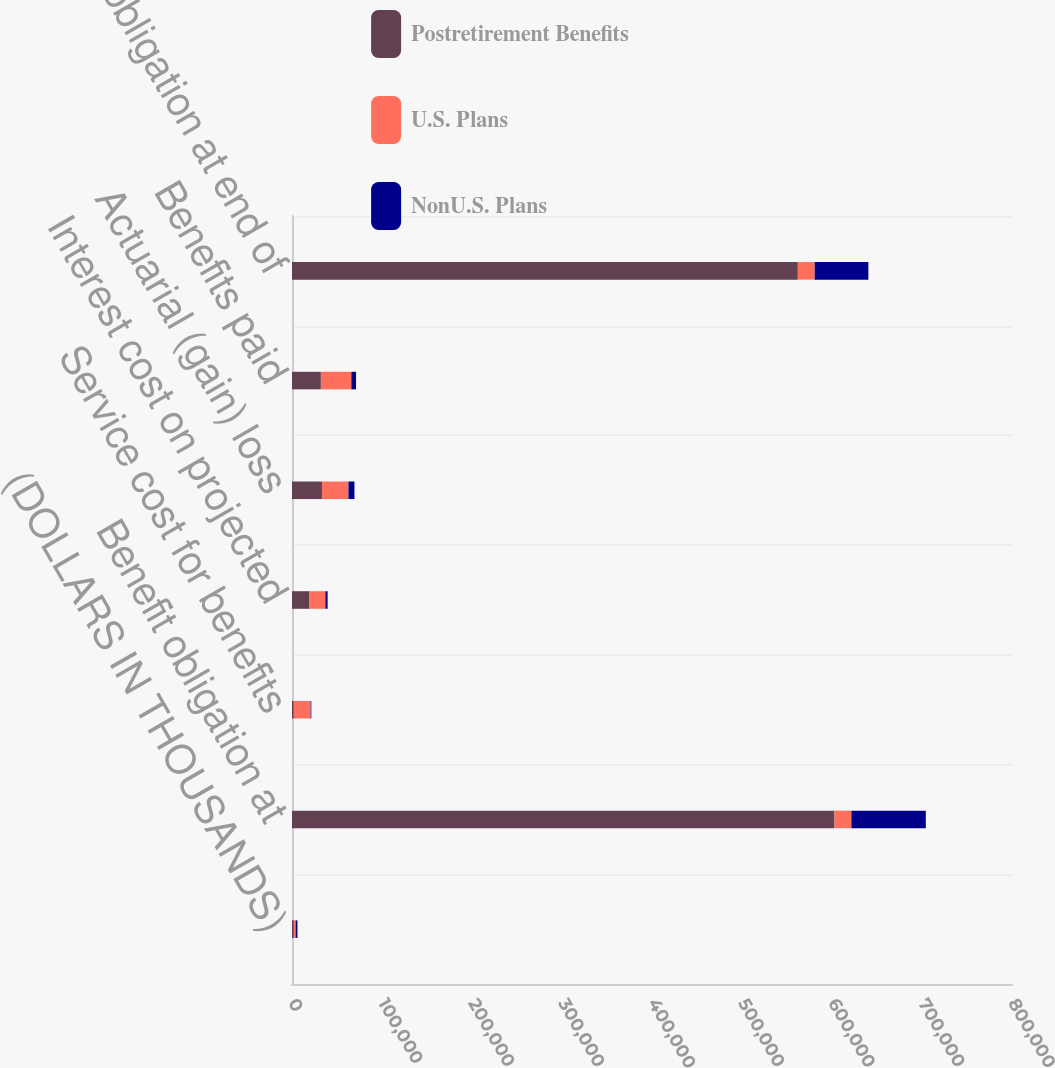Convert chart to OTSL. <chart><loc_0><loc_0><loc_500><loc_500><stacked_bar_chart><ecel><fcel>(DOLLARS IN THOUSANDS)<fcel>Benefit obligation at<fcel>Service cost for benefits<fcel>Interest cost on projected<fcel>Actuarial (gain) loss<fcel>Benefits paid<fcel>Benefit obligation at end of<nl><fcel>Postretirement Benefits<fcel>2018<fcel>602783<fcel>1971<fcel>19393<fcel>33284<fcel>32093<fcel>562043<nl><fcel>U.S. Plans<fcel>2018<fcel>18738<fcel>18738<fcel>17704<fcel>29433<fcel>33862<fcel>18738<nl><fcel>NonU.S. Plans<fcel>2018<fcel>82714<fcel>755<fcel>2460<fcel>6677<fcel>5200<fcel>59625<nl></chart> 